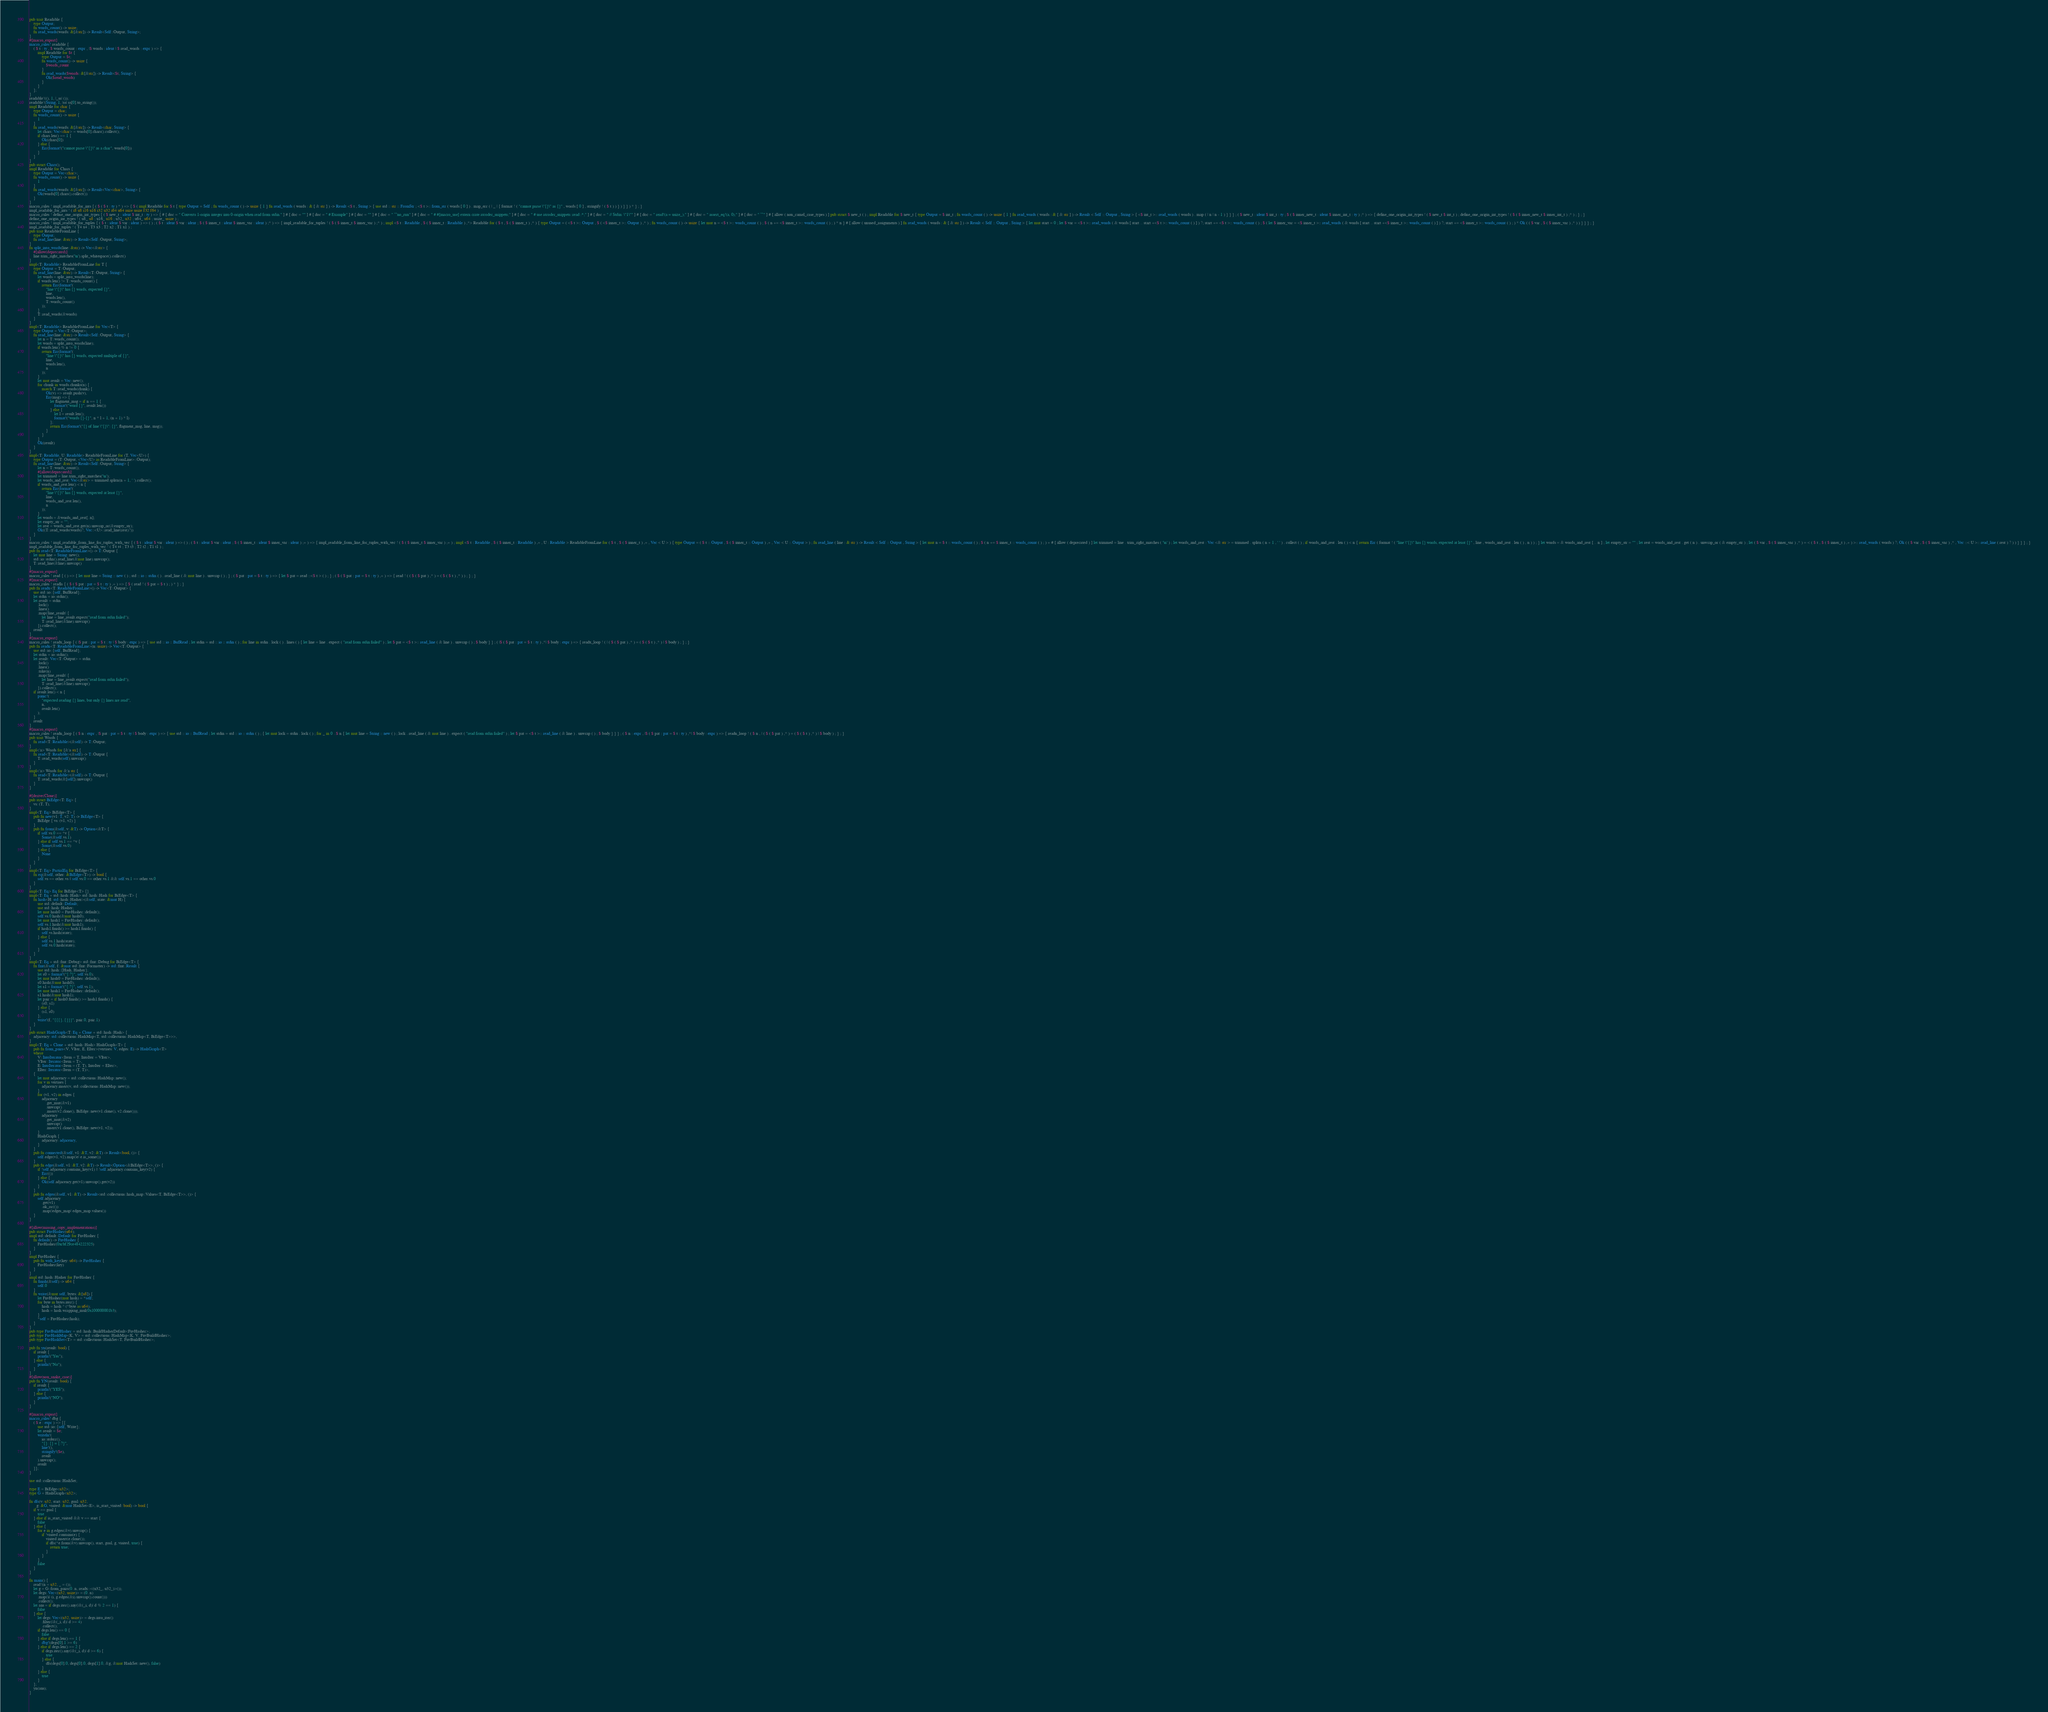<code> <loc_0><loc_0><loc_500><loc_500><_Rust_>pub trait Readable {
    type Output;
    fn words_count() -> usize;
    fn read_words(words: &[&str]) -> Result<Self::Output, String>;
}
#[macro_export]
macro_rules! readable {
    ( $ t : ty , $ words_count : expr , |$ words : ident | $ read_words : expr ) => {
        impl Readable for $t {
            type Output = $t;
            fn words_count() -> usize {
                $words_count
            }
            fn read_words($words: &[&str]) -> Result<$t, String> {
                Ok($read_words)
            }
        }
    };
}
readable!((), 1, |_ss| ());
readable!(String, 1, |ss| ss[0].to_string());
impl Readable for char {
    type Output = char;
    fn words_count() -> usize {
        1
    }
    fn read_words(words: &[&str]) -> Result<char, String> {
        let chars: Vec<char> = words[0].chars().collect();
        if chars.len() == 1 {
            Ok(chars[0])
        } else {
            Err(format!("cannot parse \"{}\" as a char", words[0]))
        }
    }
}
pub struct Chars();
impl Readable for Chars {
    type Output = Vec<char>;
    fn words_count() -> usize {
        1
    }
    fn read_words(words: &[&str]) -> Result<Vec<char>, String> {
        Ok(words[0].chars().collect())
    }
}
macro_rules ! impl_readable_for_ints { ( $ ( $ t : ty ) * ) => { $ ( impl Readable for $ t { type Output = Self ; fn words_count ( ) -> usize { 1 } fn read_words ( words : & [ & str ] ) -> Result <$ t , String > { use std :: str :: FromStr ; <$ t >:: from_str ( words [ 0 ] ) . map_err ( | _ | { format ! ( "cannot parse \"{}\" as {}" , words [ 0 ] , stringify ! ( $ t ) ) } ) } } ) * } ; }
impl_readable_for_ints ! ( i8 u8 i16 u16 i32 u32 i64 u64 isize usize f32 f64 ) ;
macro_rules ! define_one_origin_int_types { ( $ new_t : ident $ int_t : ty ) => { # [ doc = " Converts 1-origin integer into 0-origin when read from stdin." ] # [ doc = "" ] # [ doc = " # Example" ] # [ doc = "" ] # [ doc = " ```no_run" ] # [ doc = " # #[macro_use] extern crate atcoder_snippets;" ] # [ doc = " # use atcoder_snippets::read::*;" ] # [ doc = " // Stdin: \"1\"" ] # [ doc = " read!(a = usize_);" ] # [ doc = " assert_eq!(a, 0);" ] # [ doc = " ```" ] # [ allow ( non_camel_case_types ) ] pub struct $ new_t ( ) ; impl Readable for $ new_t { type Output = $ int_t ; fn words_count ( ) -> usize { 1 } fn read_words ( words : & [ & str ] ) -> Result < Self :: Output , String > { <$ int_t >:: read_words ( words ) . map ( | n | n - 1 ) } } } ; ( $ new_t : ident $ int_t : ty ; $ ( $ inner_new_t : ident $ inner_int_t : ty ) ;* ) => { define_one_origin_int_types ! ( $ new_t $ int_t ) ; define_one_origin_int_types ! ( $ ( $ inner_new_t $ inner_int_t ) ;* ) ; } ; }
define_one_origin_int_types ! ( u8_ u8 ; u16_ u16 ; u32_ u32 ; u64_ u64 ; usize_ usize ) ;
macro_rules ! impl_readable_for_tuples { ( $ t : ident $ var : ident ) => ( ) ; ( $ t : ident $ var : ident ; $ ( $ inner_t : ident $ inner_var : ident ) ;* ) => { impl_readable_for_tuples ! ( $ ( $ inner_t $ inner_var ) ;* ) ; impl <$ t : Readable , $ ( $ inner_t : Readable ) ,*> Readable for ( $ t , $ ( $ inner_t ) ,* ) { type Output = ( <$ t >:: Output , $ ( <$ inner_t >:: Output ) ,* ) ; fn words_count ( ) -> usize { let mut n = <$ t >:: words_count ( ) ; $ ( n += <$ inner_t >:: words_count ( ) ; ) * n } # [ allow ( unused_assignments ) ] fn read_words ( words : & [ & str ] ) -> Result < Self :: Output , String > { let mut start = 0 ; let $ var = <$ t >:: read_words ( & words [ start .. start +<$ t >:: words_count ( ) ] ) ?; start += <$ t >:: words_count ( ) ; $ ( let $ inner_var = <$ inner_t >:: read_words ( & words [ start .. start +<$ inner_t >:: words_count ( ) ] ) ?; start += <$ inner_t >:: words_count ( ) ; ) * Ok ( ( $ var , $ ( $ inner_var ) ,* ) ) } } } ; }
impl_readable_for_tuples ! ( T4 x4 ; T3 x3 ; T2 x2 ; T1 x1 ) ;
pub trait ReadableFromLine {
    type Output;
    fn read_line(line: &str) -> Result<Self::Output, String>;
}
fn split_into_words(line: &str) -> Vec<&str> {
    #[allow(deprecated)]
    line.trim_right_matches('\n').split_whitespace().collect()
}
impl<T: Readable> ReadableFromLine for T {
    type Output = T::Output;
    fn read_line(line: &str) -> Result<T::Output, String> {
        let words = split_into_words(line);
        if words.len() != T::words_count() {
            return Err(format!(
                "line \"{}\" has {} words, expected {}",
                line,
                words.len(),
                T::words_count()
            ));
        }
        T::read_words(&words)
    }
}
impl<T: Readable> ReadableFromLine for Vec<T> {
    type Output = Vec<T::Output>;
    fn read_line(line: &str) -> Result<Self::Output, String> {
        let n = T::words_count();
        let words = split_into_words(line);
        if words.len() % n != 0 {
            return Err(format!(
                "line \"{}\" has {} words, expected multiple of {}",
                line,
                words.len(),
                n
            ));
        }
        let mut result = Vec::new();
        for chunk in words.chunks(n) {
            match T::read_words(chunk) {
                Ok(v) => result.push(v),
                Err(msg) => {
                    let flagment_msg = if n == 1 {
                        format!("word {}", result.len())
                    } else {
                        let l = result.len();
                        format!("words {}-{}", n * l + 1, (n + 1) * l)
                    };
                    return Err(format!("{} of line \"{}\": {}", flagment_msg, line, msg));
                }
            }
        }
        Ok(result)
    }
}
impl<T: Readable, U: Readable> ReadableFromLine for (T, Vec<U>) {
    type Output = (T::Output, <Vec<U> as ReadableFromLine>::Output);
    fn read_line(line: &str) -> Result<Self::Output, String> {
        let n = T::words_count();
        #[allow(deprecated)]
        let trimmed = line.trim_right_matches('\n');
        let words_and_rest: Vec<&str> = trimmed.splitn(n + 1, ' ').collect();
        if words_and_rest.len() < n {
            return Err(format!(
                "line \"{}\" has {} words, expected at least {}",
                line,
                words_and_rest.len(),
                n
            ));
        }
        let words = &words_and_rest[..n];
        let empty_str = "";
        let rest = words_and_rest.get(n).unwrap_or(&empty_str);
        Ok((T::read_words(words)?, Vec::<U>::read_line(rest)?))
    }
}
macro_rules ! impl_readable_from_line_for_tuples_with_vec { ( $ t : ident $ var : ident ) => ( ) ; ( $ t : ident $ var : ident ; $ ( $ inner_t : ident $ inner_var : ident ) ;+ ) => { impl_readable_from_line_for_tuples_with_vec ! ( $ ( $ inner_t $ inner_var ) ;+ ) ; impl <$ t : Readable , $ ( $ inner_t : Readable ) ,+ , U : Readable > ReadableFromLine for ( $ t , $ ( $ inner_t ) ,+ , Vec < U > ) { type Output = ( $ t :: Output , $ ( $ inner_t :: Output ) ,+ , Vec < U :: Output > ) ; fn read_line ( line : & str ) -> Result < Self :: Output , String > { let mut n = $ t :: words_count ( ) ; $ ( n += $ inner_t :: words_count ( ) ; ) + # [ allow ( deprecated ) ] let trimmed = line . trim_right_matches ( '\n' ) ; let words_and_rest : Vec <& str > = trimmed . splitn ( n + 1 , ' ' ) . collect ( ) ; if words_and_rest . len ( ) < n { return Err ( format ! ( "line \"{}\" has {} words, expected at least {}" , line , words_and_rest . len ( ) , n ) ) ; } let words = & words_and_rest [ .. n ] ; let empty_str = "" ; let rest = words_and_rest . get ( n ) . unwrap_or ( & empty_str ) ; let ( $ var , $ ( $ inner_var ) ,* ) = < ( $ t , $ ( $ inner_t ) ,+ ) >:: read_words ( words ) ?; Ok ( ( $ var , $ ( $ inner_var ) ,* , Vec ::< U >:: read_line ( rest ) ? ) ) } } } ; }
impl_readable_from_line_for_tuples_with_vec ! ( T4 t4 ; T3 t3 ; T2 t2 ; T1 t1 ) ;
pub fn read<T: ReadableFromLine>() -> T::Output {
    let mut line = String::new();
    std::io::stdin().read_line(&mut line).unwrap();
    T::read_line(&line).unwrap()
}
#[macro_export]
macro_rules ! read { ( ) => { let mut line = String :: new ( ) ; std :: io :: stdin ( ) . read_line ( & mut line ) . unwrap ( ) ; } ; ( $ pat : pat = $ t : ty ) => { let $ pat = read ::<$ t > ( ) ; } ; ( $ ( $ pat : pat = $ t : ty ) ,+ ) => { read ! ( ( $ ( $ pat ) ,* ) = ( $ ( $ t ) ,* ) ) ; } ; }
#[macro_export]
macro_rules ! readls { ( $ ( $ pat : pat = $ t : ty ) ,+ ) => { $ ( read ! ( $ pat = $ t ) ; ) * } ; }
pub fn readx<T: ReadableFromLine>() -> Vec<T::Output> {
    use std::io::{self, BufRead};
    let stdin = io::stdin();
    let result = stdin
        .lock()
        .lines()
        .map(|line_result| {
            let line = line_result.expect("read from stdin failed");
            T::read_line(&line).unwrap()
        }).collect();
    result
}
#[macro_export]
macro_rules ! readx_loop { ( |$ pat : pat = $ t : ty | $ body : expr ) => { use std :: io :: BufRead ; let stdin = std :: io :: stdin ( ) ; for line in stdin . lock ( ) . lines ( ) { let line = line . expect ( "read from stdin failed" ) ; let $ pat = <$ t >:: read_line ( & line ) . unwrap ( ) ; $ body } } ; ( |$ ( $ pat : pat = $ t : ty ) ,*| $ body : expr ) => { readx_loop ! ( | ( $ ( $ pat ) ,* ) = ( $ ( $ t ) ,* ) | $ body ) ; } ; }
pub fn readn<T: ReadableFromLine>(n: usize) -> Vec<T::Output> {
    use std::io::{self, BufRead};
    let stdin = io::stdin();
    let result: Vec<T::Output> = stdin
        .lock()
        .lines()
        .take(n)
        .map(|line_result| {
            let line = line_result.expect("read from stdin failed");
            T::read_line(&line).unwrap()
        }).collect();
    if result.len() < n {
        panic!(
            "expected reading {} lines, but only {} lines are read",
            n,
            result.len()
        );
    }
    result
}
#[macro_export]
macro_rules ! readn_loop { ( $ n : expr , |$ pat : pat = $ t : ty | $ body : expr ) => { use std :: io :: BufRead ; let stdin = std :: io :: stdin ( ) ; { let mut lock = stdin . lock ( ) ; for _ in 0 ..$ n { let mut line = String :: new ( ) ; lock . read_line ( & mut line ) . expect ( "read from stdin failed" ) ; let $ pat = <$ t >:: read_line ( & line ) . unwrap ( ) ; $ body } } } ; ( $ n : expr , |$ ( $ pat : pat = $ t : ty ) ,*| $ body : expr ) => { readn_loop ! ( $ n , | ( $ ( $ pat ) ,* ) = ( $ ( $ t ) ,* ) | $ body ) ; } ; }
pub trait Words {
    fn read<T: Readable>(&self) -> T::Output;
}
impl<'a> Words for [&'a str] {
    fn read<T: Readable>(&self) -> T::Output {
        T::read_words(self).unwrap()
    }
}
impl<'a> Words for &'a str {
    fn read<T: Readable>(&self) -> T::Output {
        T::read_words(&[self]).unwrap()
    }
}

#[derive(Clone)]
pub struct BiEdge<T: Eq> {
    vs: (T, T),
}
impl<T: Eq> BiEdge<T> {
    pub fn new(v1: T, v2: T) -> BiEdge<T> {
        BiEdge { vs: (v1, v2) }
    }
    pub fn from(&self, v: &T) -> Option<&T> {
        if self.vs.0 == *v {
            Some(&self.vs.1)
        } else if self.vs.1 == *v {
            Some(&self.vs.0)
        } else {
            None
        }
    }
}
impl<T: Eq> PartialEq for BiEdge<T> {
    fn eq(&self, other: &BiEdge<T>) -> bool {
        self.vs == other.vs || self.vs.0 == other.vs.1 && self.vs.1 == other.vs.0
    }
}
impl<T: Eq> Eq for BiEdge<T> {}
impl<T: Eq + std::hash::Hash> std::hash::Hash for BiEdge<T> {
    fn hash<H: std::hash::Hasher>(&self, state: &mut H) {
        use std::default::Default;
        use std::hash::Hasher;
        let mut hash0 = FnvHasher::default();
        self.vs.0.hash(&mut hash0);
        let mut hash1 = FnvHasher::default();
        self.vs.1.hash(&mut hash1);
        if hash1.finish() >= hash1.finish() {
            self.vs.hash(state);
        } else {
            self.vs.1.hash(state);
            self.vs.0.hash(state);
        }
    }
}
impl<T: Eq + std::fmt::Debug> std::fmt::Debug for BiEdge<T> {
    fn fmt(&self, f: &mut std::fmt::Formatter) -> std::fmt::Result {
        use std::hash::{Hash, Hasher};
        let s0 = format!("{:?}", self.vs.0);
        let mut hash0 = FnvHasher::default();
        s0.hash(&mut hash0);
        let s1 = format!("{:?}", self.vs.1);
        let mut hash1 = FnvHasher::default();
        s1.hash(&mut hash1);
        let pair = if hash0.finish() >= hash1.finish() {
            (s0, s1)
        } else {
            (s1, s0)
        };
        write!(f, "{{{}, {}}}", pair.0, pair.1)
    }
}
pub struct HashGraph<T: Eq + Clone + std::hash::Hash> {
    adjacency: std::collections::HashMap<T, std::collections::HashMap<T, BiEdge<T>>>,
}
impl<T: Eq + Clone + std::hash::Hash> HashGraph<T> {
    pub fn from_pairs<V, VIter, E, EIter>(vertises: V, edges: E) -> HashGraph<T>
    where
        V: IntoIterator<Item = T, IntoIter = VIter>,
        VIter: Iterator<Item = T>,
        E: IntoIterator<Item = (T, T), IntoIter = EIter>,
        EIter: Iterator<Item = (T, T)>,
    {
        let mut adjacency = std::collections::HashMap::new();
        for v in vertises {
            adjacency.insert(v, std::collections::HashMap::new());
        }
        for (v1, v2) in edges {
            adjacency
                .get_mut(&v1)
                .unwrap()
                .insert(v2.clone(), BiEdge::new(v1.clone(), v2.clone()));
            adjacency
                .get_mut(&v2)
                .unwrap()
                .insert(v1.clone(), BiEdge::new(v1, v2));
        }
        HashGraph {
            adjacency: adjacency,
        }
    }
    pub fn connected(&self, v1: &T, v2: &T) -> Result<bool, ()> {
        self.edge(v1, v2).map(|e| e.is_some())
    }
    pub fn edge(&self, v1: &T, v2: &T) -> Result<Option<&BiEdge<T>>, ()> {
        if !self.adjacency.contains_key(v1) || !self.adjacency.contains_key(v2) {
            Err(())
        } else {
            Ok(self.adjacency.get(v1).unwrap().get(v2))
        }
    }
    pub fn edges(&self, v1: &T) -> Result<std::collections::hash_map::Values<T, BiEdge<T>>, ()> {
        self.adjacency
            .get(v1)
            .ok_or(())
            .map(|edges_map| edges_map.values())
    }
}

#[allow(missing_copy_implementations)]
pub struct FnvHasher(u64);
impl std::default::Default for FnvHasher {
    fn default() -> FnvHasher {
        FnvHasher(0xcbf29ce484222325)
    }
}
impl FnvHasher {
    pub fn with_key(key: u64) -> FnvHasher {
        FnvHasher(key)
    }
}
impl std::hash::Hasher for FnvHasher {
    fn finish(&self) -> u64 {
        self.0
    }
    fn write(&mut self, bytes: &[u8]) {
        let FnvHasher(mut hash) = *self;
        for byte in bytes.iter() {
            hash = hash ^ (*byte as u64);
            hash = hash.wrapping_mul(0x100000001b3);
        }
        *self = FnvHasher(hash);
    }
}
pub type FnvBuildHasher = std::hash::BuildHasherDefault<FnvHasher>;
pub type FnvHashMap<K, V> = std::collections::HashMap<K, V, FnvBuildHasher>;
pub type FnvHashSet<T> = std::collections::HashSet<T, FnvBuildHasher>;

pub fn yn(result: bool) {
    if result {
        println!("Yes");
    } else {
        println!("No");
    }
}
#[allow(non_snake_case)]
pub fn YN(result: bool) {
    if result {
        println!("YES");
    } else {
        println!("NO");
    }
}

#[macro_export]
macro_rules! dbg {
    ( $ e : expr ) => {{
        use std::io::{self, Write};
        let result = $e;
        writeln!(
            io::stderr(),
            "{}: {} = {:?}",
            line!(),
            stringify!($e),
            result
        ).unwrap();
        result
    }};
}

use std::collections::HashSet;

type E = BiEdge<u32>;
type G = HashGraph<u32>;

fn dfs(v: u32, start: u32, goal: u32,
       g: &G, visited: &mut HashSet<E>, is_start_visited: bool) -> bool {
    if v == goal {
        true
    } else if is_start_visited && v == start {
        false
    } else {
        for e in g.edges(&v).unwrap() {
            if !visited.contains(e) {
                visited.insert(e.clone());
                if dfs(*e.from(&v).unwrap(), start, goal, g, visited, true) {
                    return true;
                }
            }
        }
        false
    }
}

fn main() {
    read!(n = u32, _ = ());
    let g = G::from_pairs(0..n, readx::<(u32_, u32_)>());
    let degs: Vec<(u32, usize)> = (0..n)
        .map(|i| (i, g.edges(&i).unwrap().count()))
        .collect();
    let ans = if degs.iter().any(|&(_i, d)| d % 2 == 1) {
        false
    } else {
        let degs: Vec<(u32, usize)> = degs.into_iter()
            .filter(|&(_i, d)| d >= 4)
            .collect();
        if degs.len() == 0 {
            false
        } else if degs.len() == 1 {
            dbg!(degs[0].1 >= 6)
        } else if degs.len() == 2 {
            if degs.iter().any(|&(_i, d)| d >= 6) {
                true
            } else {
                dfs(degs[0].0, degs[0].0, degs[1].0, &g, &mut HashSet::new(), false)
            }
        } else {
            true
        }
    };
    yn(ans);
}
</code> 